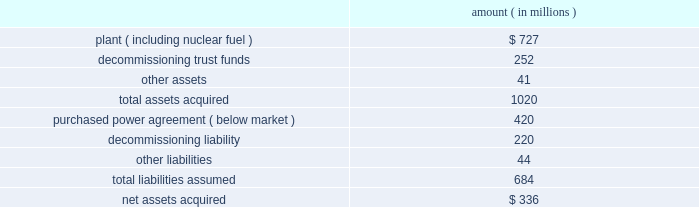Entergy corporation and subsidiaries notes to financial statements ouachita in september 2008 , entergy arkansas purchased the ouachita plant , a 789 mw three-train gas-fired combined cycle generating turbine ( ccgt ) electric power plant located 20 miles south of the arkansas state line near sterlington , louisiana , for approximately $ 210 million from a subsidiary of cogentrix energy , inc .
Entergy arkansas received the plant , materials and supplies , and related real estate in the transaction .
The ferc and the apsc approved the acquisition .
The apsc also approved the recovery of the acquisition and ownership costs through a rate rider and the planned sale of one-third of the capacity and energy to entergy gulf states louisiana .
The lpsc also approved the purchase of one-third of the capacity and energy by entergy gulf states louisiana , subject to certain conditions , including a study to determine the costs and benefits of entergy gulf states louisiana exercising an option to purchase one-third of the plant ( unit 3 ) from entergy arkansas .
Entergy gulf states louisiana is scheduled to report the results of that study by march 30 , 2009 .
Palisades in april 2007 , entergy's non-utility nuclear business purchased the 798 mw palisades nuclear energy plant located near south haven , michigan from consumers energy company for a net cash payment of $ 336 million .
Entergy received the plant , nuclear fuel , inventories , and other assets .
The liability to decommission the plant , as well as related decommissioning trust funds , was also transferred to entergy's non-utility nuclear business .
Entergy's non-utility nuclear business executed a unit-contingent , 15-year purchased power agreement ( ppa ) with consumers energy for 100% ( 100 % ) of the plant's output , excluding any future uprates .
Prices under the ppa range from $ 43.50/mwh in 2007 to $ 61.50/mwh in 2022 , and the average price under the ppa is $ 51/mwh .
In the first quarter 2007 , the nrc renewed palisades' operating license until 2031 .
As part of the transaction , entergy's non- utility nuclear business assumed responsibility for spent fuel at the decommissioned big rock point nuclear plant , which is located near charlevoix , michigan .
Palisades' financial results since april 2007 are included in entergy's non-utility nuclear business segment .
The table summarizes the assets acquired and liabilities assumed at the date of acquisition .
Amount ( in millions ) .
Subsequent to the closing , entergy received approximately $ 6 million from consumers energy company as part of the post-closing adjustment defined in the asset sale agreement .
The post-closing adjustment amount resulted in an approximately $ 6 million reduction in plant and a corresponding reduction in other liabilities .
For the ppa , which was at below-market prices at the time of the acquisition , non-utility nuclear will amortize a liability to revenue over the life of the agreement .
The amount that will be amortized each period is based upon the difference between the present value calculated at the date of acquisition of each year's difference between revenue under the agreement and revenue based on estimated market prices .
Amounts amortized to revenue were $ 76 .
What portion of the total acquired asset is composed of decommissioning trust funds? 
Computations: (252 / 1020)
Answer: 0.24706. 